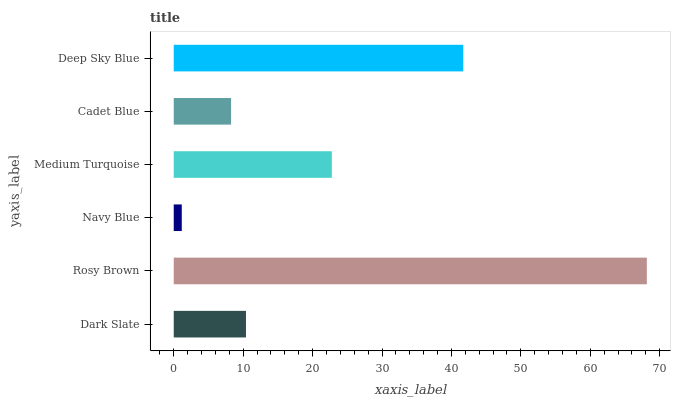Is Navy Blue the minimum?
Answer yes or no. Yes. Is Rosy Brown the maximum?
Answer yes or no. Yes. Is Rosy Brown the minimum?
Answer yes or no. No. Is Navy Blue the maximum?
Answer yes or no. No. Is Rosy Brown greater than Navy Blue?
Answer yes or no. Yes. Is Navy Blue less than Rosy Brown?
Answer yes or no. Yes. Is Navy Blue greater than Rosy Brown?
Answer yes or no. No. Is Rosy Brown less than Navy Blue?
Answer yes or no. No. Is Medium Turquoise the high median?
Answer yes or no. Yes. Is Dark Slate the low median?
Answer yes or no. Yes. Is Rosy Brown the high median?
Answer yes or no. No. Is Medium Turquoise the low median?
Answer yes or no. No. 